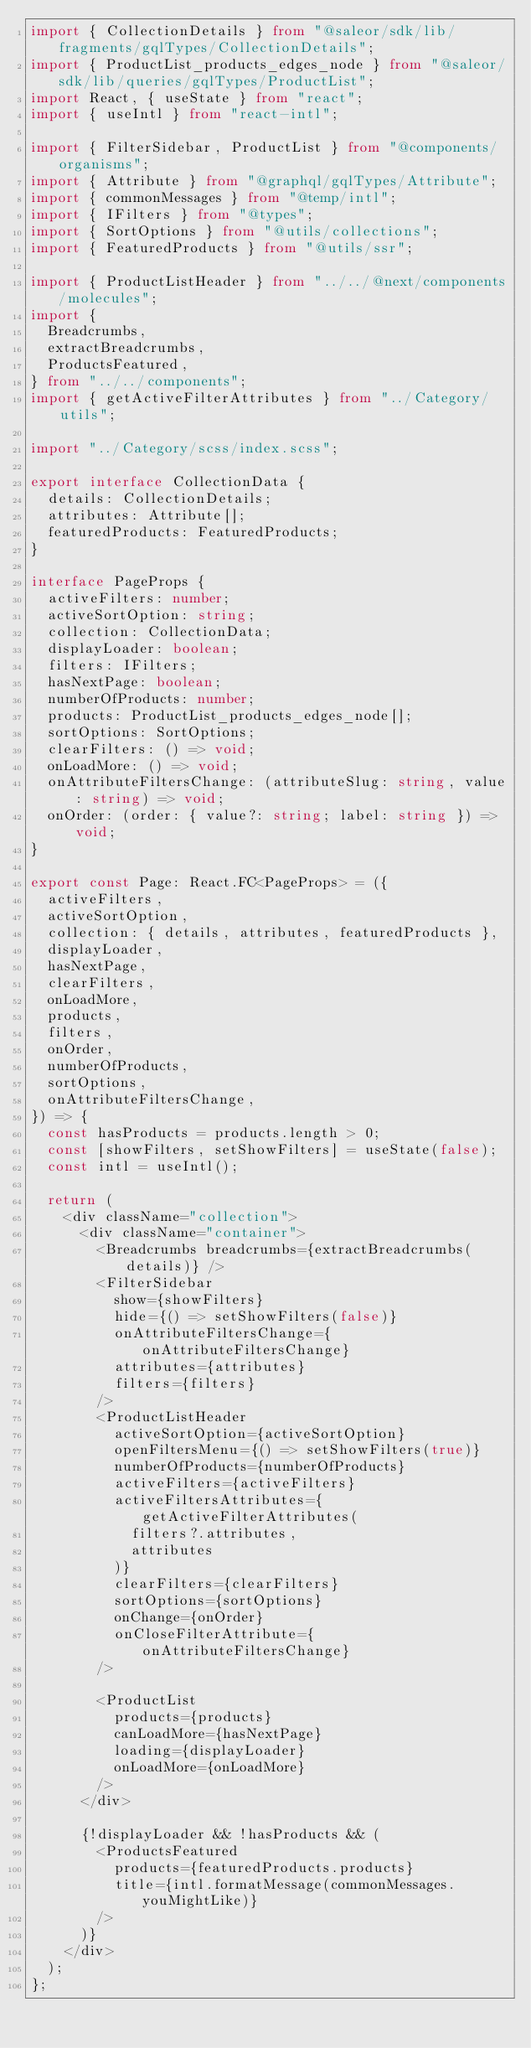Convert code to text. <code><loc_0><loc_0><loc_500><loc_500><_TypeScript_>import { CollectionDetails } from "@saleor/sdk/lib/fragments/gqlTypes/CollectionDetails";
import { ProductList_products_edges_node } from "@saleor/sdk/lib/queries/gqlTypes/ProductList";
import React, { useState } from "react";
import { useIntl } from "react-intl";

import { FilterSidebar, ProductList } from "@components/organisms";
import { Attribute } from "@graphql/gqlTypes/Attribute";
import { commonMessages } from "@temp/intl";
import { IFilters } from "@types";
import { SortOptions } from "@utils/collections";
import { FeaturedProducts } from "@utils/ssr";

import { ProductListHeader } from "../../@next/components/molecules";
import {
  Breadcrumbs,
  extractBreadcrumbs,
  ProductsFeatured,
} from "../../components";
import { getActiveFilterAttributes } from "../Category/utils";

import "../Category/scss/index.scss";

export interface CollectionData {
  details: CollectionDetails;
  attributes: Attribute[];
  featuredProducts: FeaturedProducts;
}

interface PageProps {
  activeFilters: number;
  activeSortOption: string;
  collection: CollectionData;
  displayLoader: boolean;
  filters: IFilters;
  hasNextPage: boolean;
  numberOfProducts: number;
  products: ProductList_products_edges_node[];
  sortOptions: SortOptions;
  clearFilters: () => void;
  onLoadMore: () => void;
  onAttributeFiltersChange: (attributeSlug: string, value: string) => void;
  onOrder: (order: { value?: string; label: string }) => void;
}

export const Page: React.FC<PageProps> = ({
  activeFilters,
  activeSortOption,
  collection: { details, attributes, featuredProducts },
  displayLoader,
  hasNextPage,
  clearFilters,
  onLoadMore,
  products,
  filters,
  onOrder,
  numberOfProducts,
  sortOptions,
  onAttributeFiltersChange,
}) => {
  const hasProducts = products.length > 0;
  const [showFilters, setShowFilters] = useState(false);
  const intl = useIntl();

  return (
    <div className="collection">
      <div className="container">
        <Breadcrumbs breadcrumbs={extractBreadcrumbs(details)} />
        <FilterSidebar
          show={showFilters}
          hide={() => setShowFilters(false)}
          onAttributeFiltersChange={onAttributeFiltersChange}
          attributes={attributes}
          filters={filters}
        />
        <ProductListHeader
          activeSortOption={activeSortOption}
          openFiltersMenu={() => setShowFilters(true)}
          numberOfProducts={numberOfProducts}
          activeFilters={activeFilters}
          activeFiltersAttributes={getActiveFilterAttributes(
            filters?.attributes,
            attributes
          )}
          clearFilters={clearFilters}
          sortOptions={sortOptions}
          onChange={onOrder}
          onCloseFilterAttribute={onAttributeFiltersChange}
        />

        <ProductList
          products={products}
          canLoadMore={hasNextPage}
          loading={displayLoader}
          onLoadMore={onLoadMore}
        />
      </div>

      {!displayLoader && !hasProducts && (
        <ProductsFeatured
          products={featuredProducts.products}
          title={intl.formatMessage(commonMessages.youMightLike)}
        />
      )}
    </div>
  );
};
</code> 